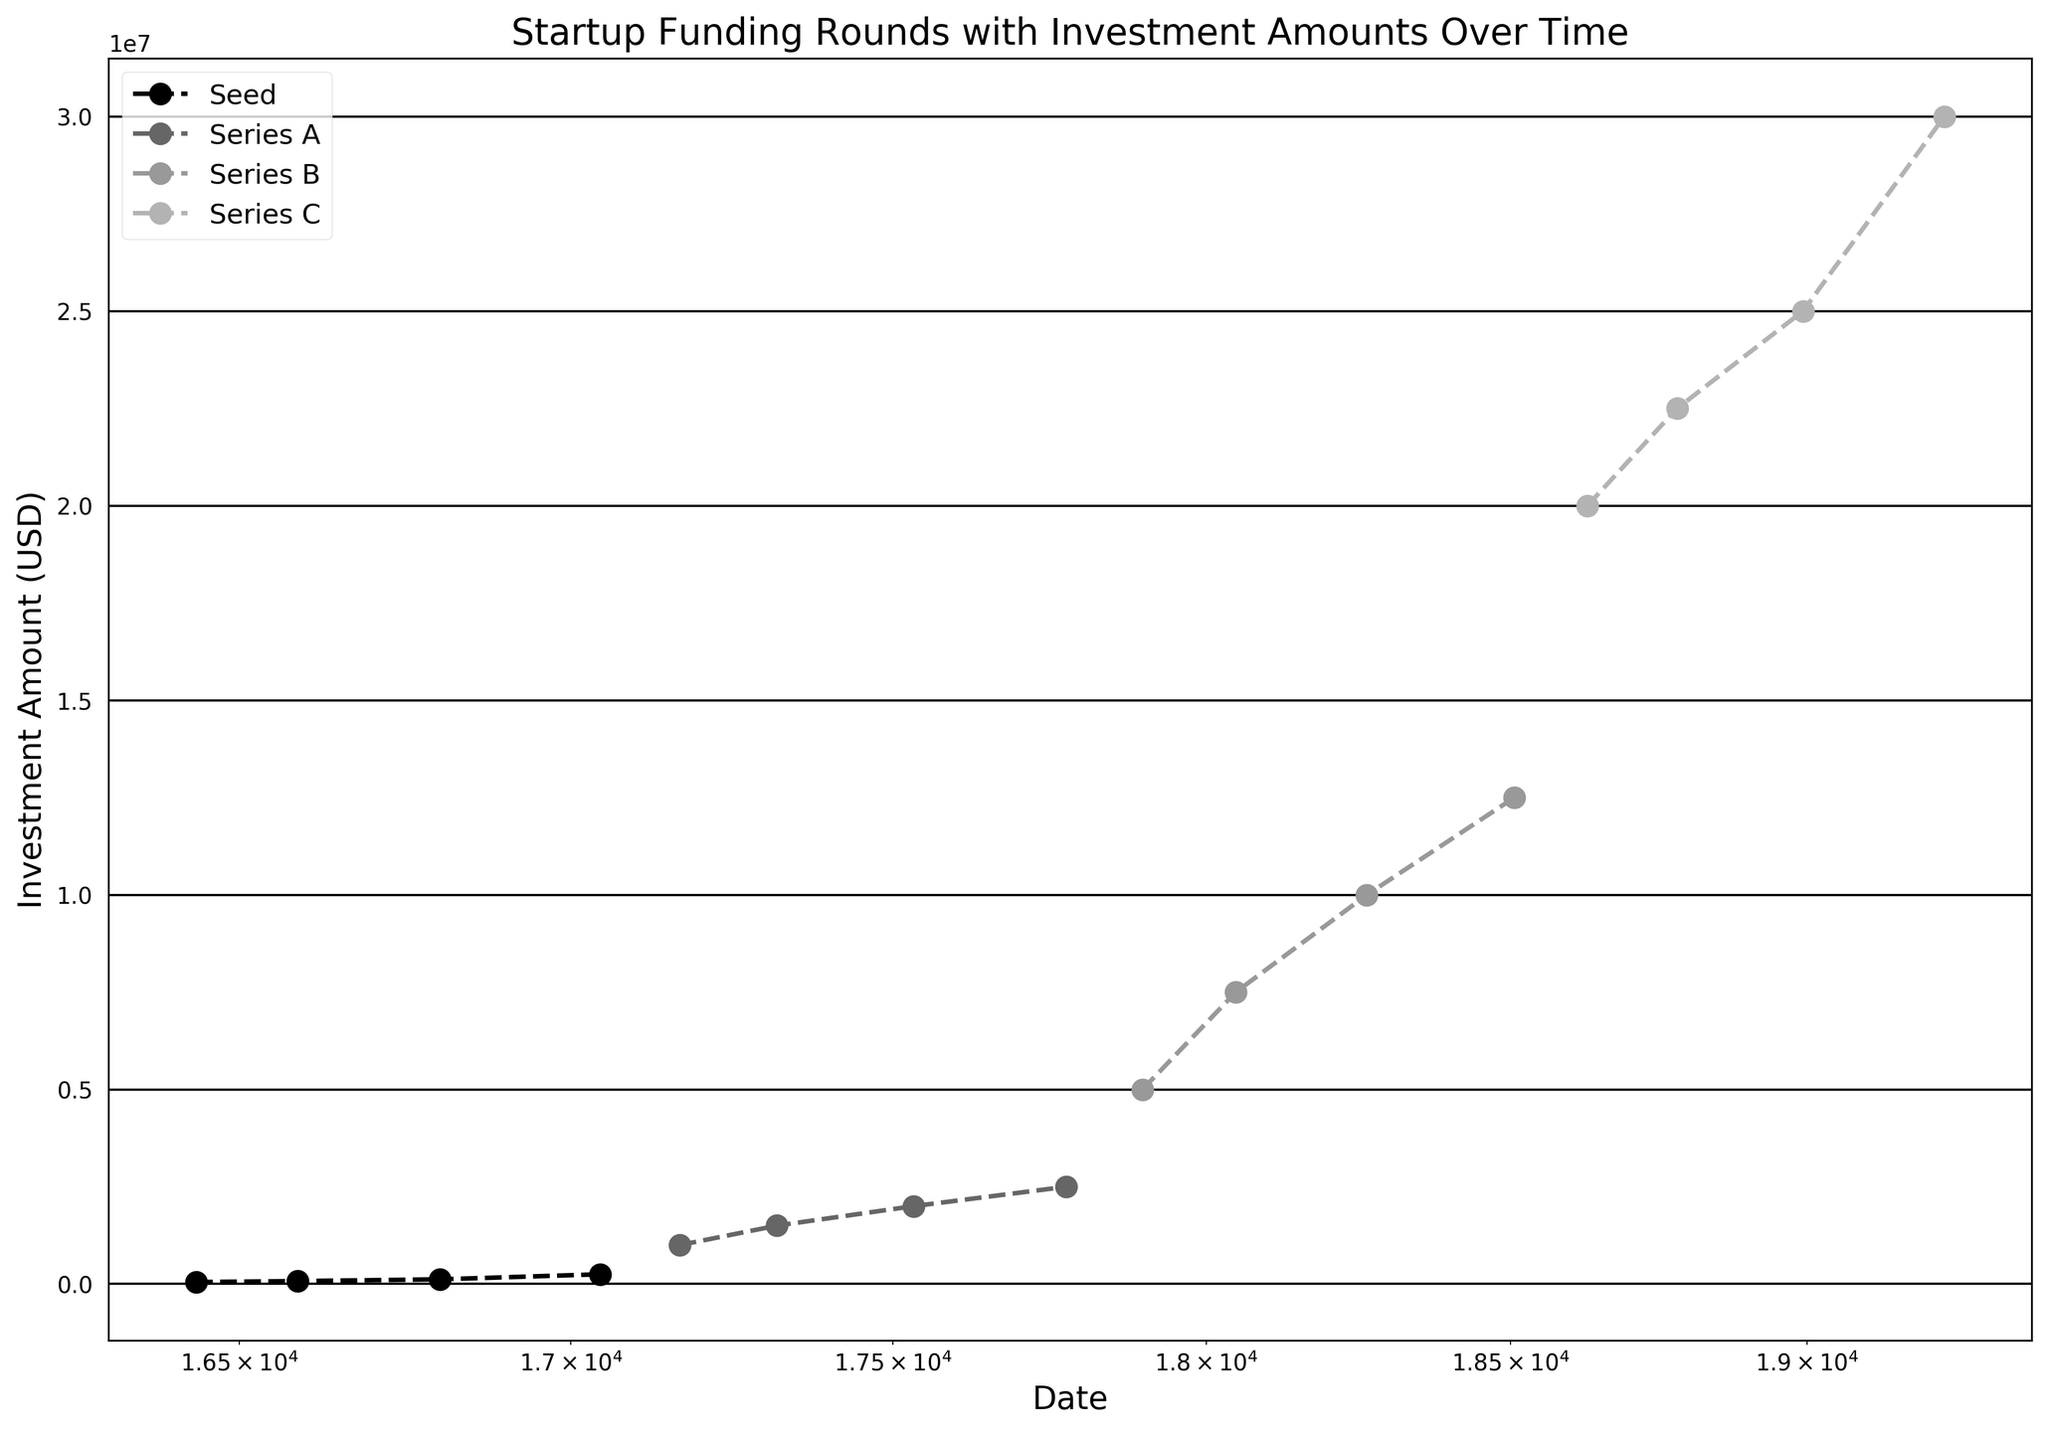What's the overall trend in investment amounts over time? Looking at the figure, we can see that the investment amounts generally increase over time, progressing from thousands to millions of dollars. This upward trend is consistent across all rounds from Seed to Series C.
Answer: Increasing Which funding round shows the highest investment amount? From the figure, Series C funding round, represented by a distinct visual style, reaches the highest investment amount of USD 30,000,000.
Answer: Series C How has the investment amount changed between the Seed round and Series A round? By comparing the plotted points, we see that the investment amount increased significantly from the highest Seed round investment of USD 250,000 to the lowest Series A round investment of USD 1,000,000, indicating notable growth.
Answer: Increased Which year first saw an investment amount of USD 5,000,000? By examining the plotted points, we can see that 2019 was the first year to have an investment amount of USD 5,000,000 in the Series B round.
Answer: 2019 What is the difference between the highest and lowest investments in the Series C round? Observing the Series C round, the highest investment is USD 30,000,000 and the lowest is USD 20,000,000. The difference between these amounts is USD 10,000,000.
Answer: USD 10,000,000 Which funding round has the most stable investment amounts over time? From the visual inspection of the figure, the Series C round shows a relatively stable increase in investment amounts, with incremental growth and few fluctuations.
Answer: Series C What is the range of investment amounts in the Series B round? Observing the plotted points for Series B, the lowest investment amount is USD 5,000,000 and the highest is USD 12,500,000, giving a range of USD 7,500,000.
Answer: USD 7,500,000 What's the investment amount in Series A around mid-2018? Checking the plotted points for Series A in mid-2018, the investment amount is USD 2,000,000.
Answer: USD 2,000,000 